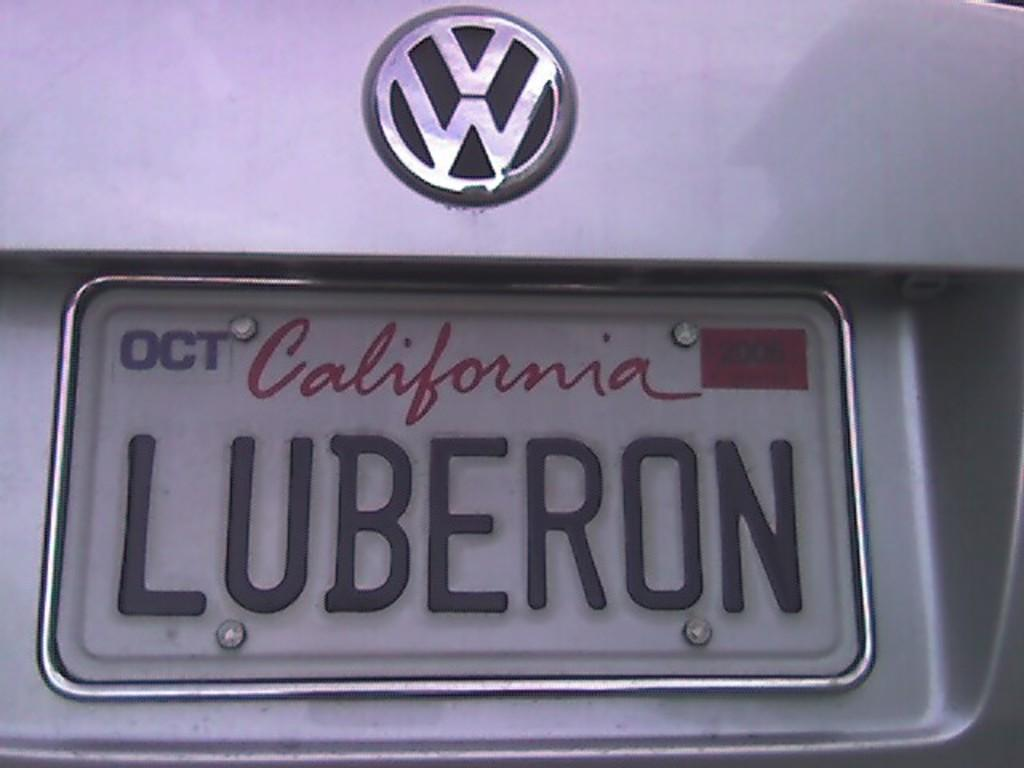<image>
Render a clear and concise summary of the photo. A VW car with a California license plate reads LUBERON 